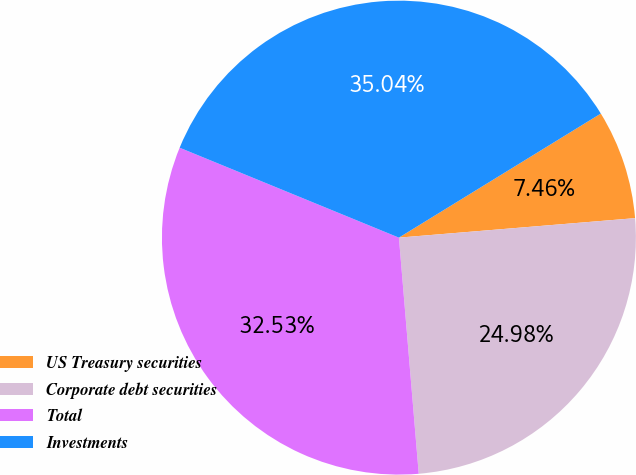Convert chart to OTSL. <chart><loc_0><loc_0><loc_500><loc_500><pie_chart><fcel>US Treasury securities<fcel>Corporate debt securities<fcel>Total<fcel>Investments<nl><fcel>7.46%<fcel>24.98%<fcel>32.53%<fcel>35.04%<nl></chart> 